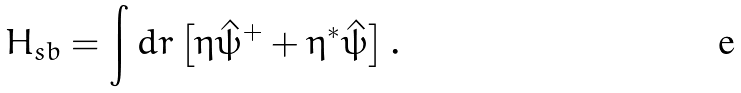Convert formula to latex. <formula><loc_0><loc_0><loc_500><loc_500>H _ { s b } = \int d { r } \left [ \eta { \hat { \psi } } ^ { + } + \eta ^ { \ast } { \hat { \psi } } \right ] .</formula> 